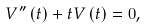<formula> <loc_0><loc_0><loc_500><loc_500>V ^ { \prime \prime } \left ( t \right ) + t V \left ( t \right ) = 0 ,</formula> 